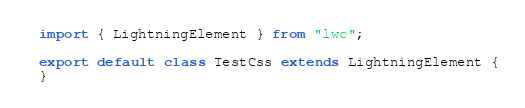Convert code to text. <code><loc_0><loc_0><loc_500><loc_500><_JavaScript_>import { LightningElement } from "lwc";

export default class TestCss extends LightningElement {
}</code> 